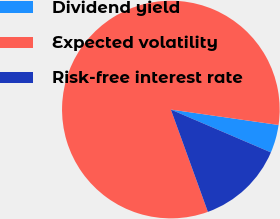<chart> <loc_0><loc_0><loc_500><loc_500><pie_chart><fcel>Dividend yield<fcel>Expected volatility<fcel>Risk-free interest rate<nl><fcel>4.18%<fcel>82.79%<fcel>13.03%<nl></chart> 